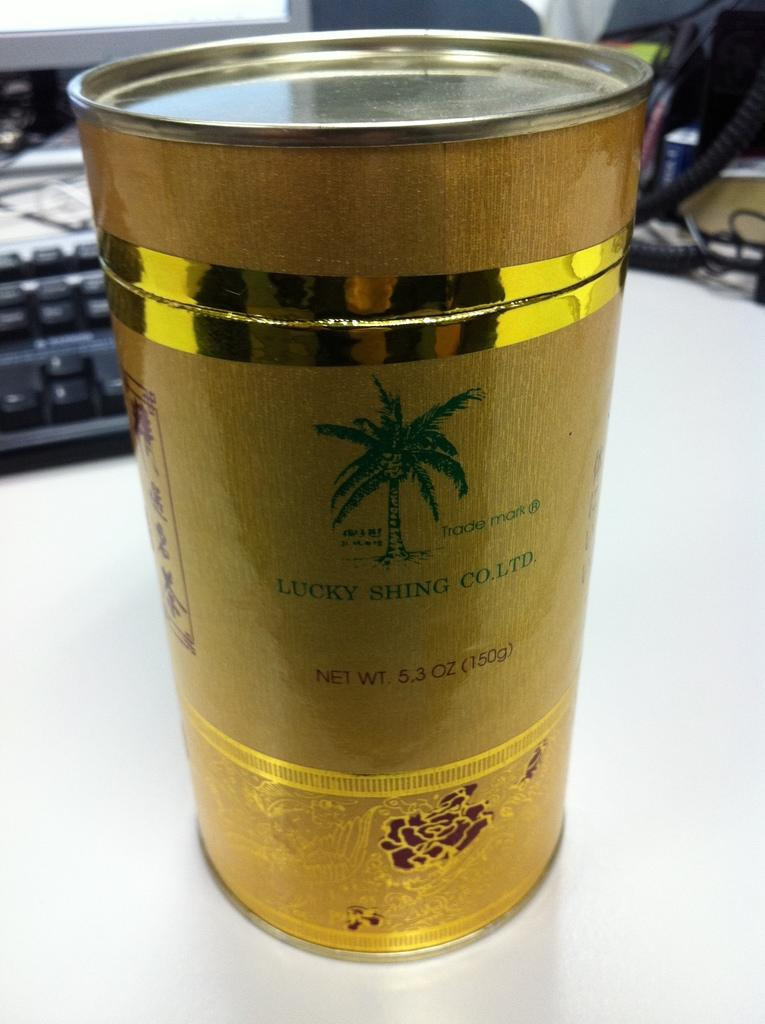<image>
Render a clear and concise summary of the photo. A gold canister from Lucky Shing Co. Ltd. weighs 5.3 oz. 